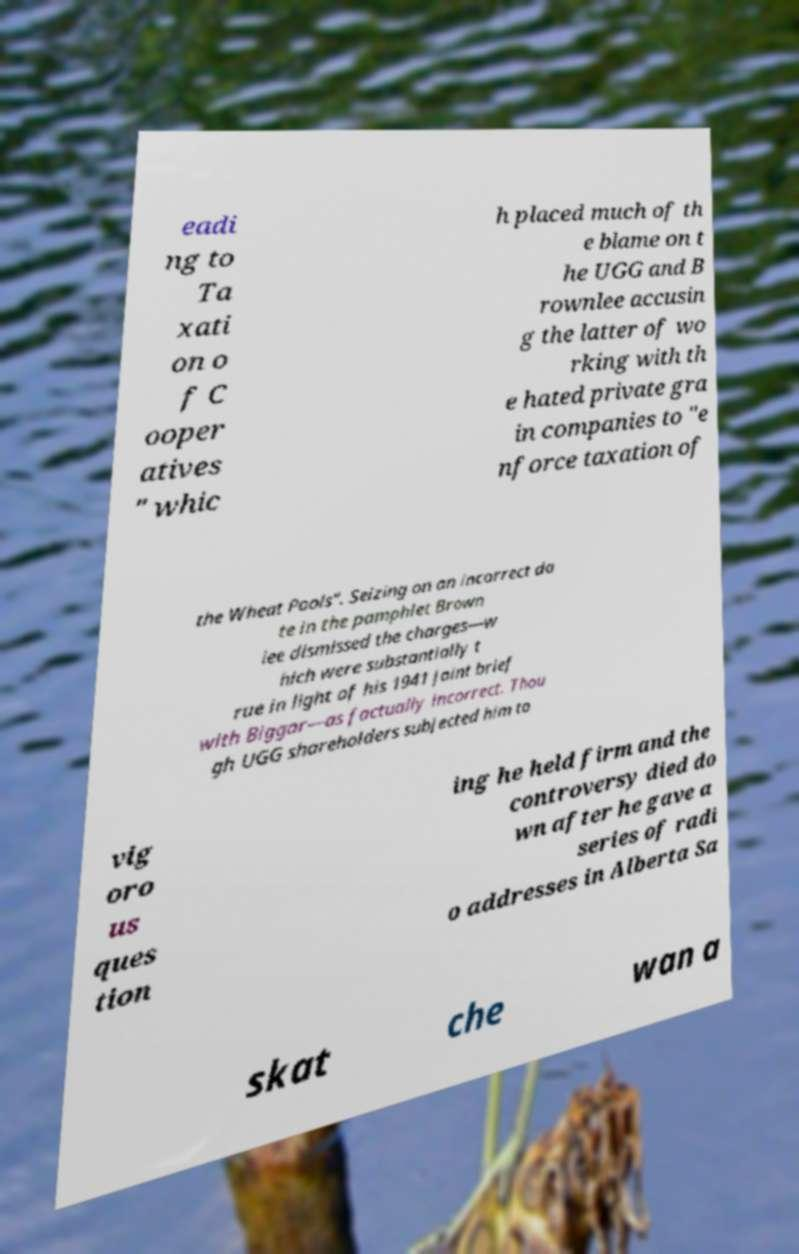Can you read and provide the text displayed in the image?This photo seems to have some interesting text. Can you extract and type it out for me? eadi ng to Ta xati on o f C ooper atives " whic h placed much of th e blame on t he UGG and B rownlee accusin g the latter of wo rking with th e hated private gra in companies to "e nforce taxation of the Wheat Pools". Seizing on an incorrect da te in the pamphlet Brown lee dismissed the charges—w hich were substantially t rue in light of his 1941 joint brief with Biggar—as factually incorrect. Thou gh UGG shareholders subjected him to vig oro us ques tion ing he held firm and the controversy died do wn after he gave a series of radi o addresses in Alberta Sa skat che wan a 